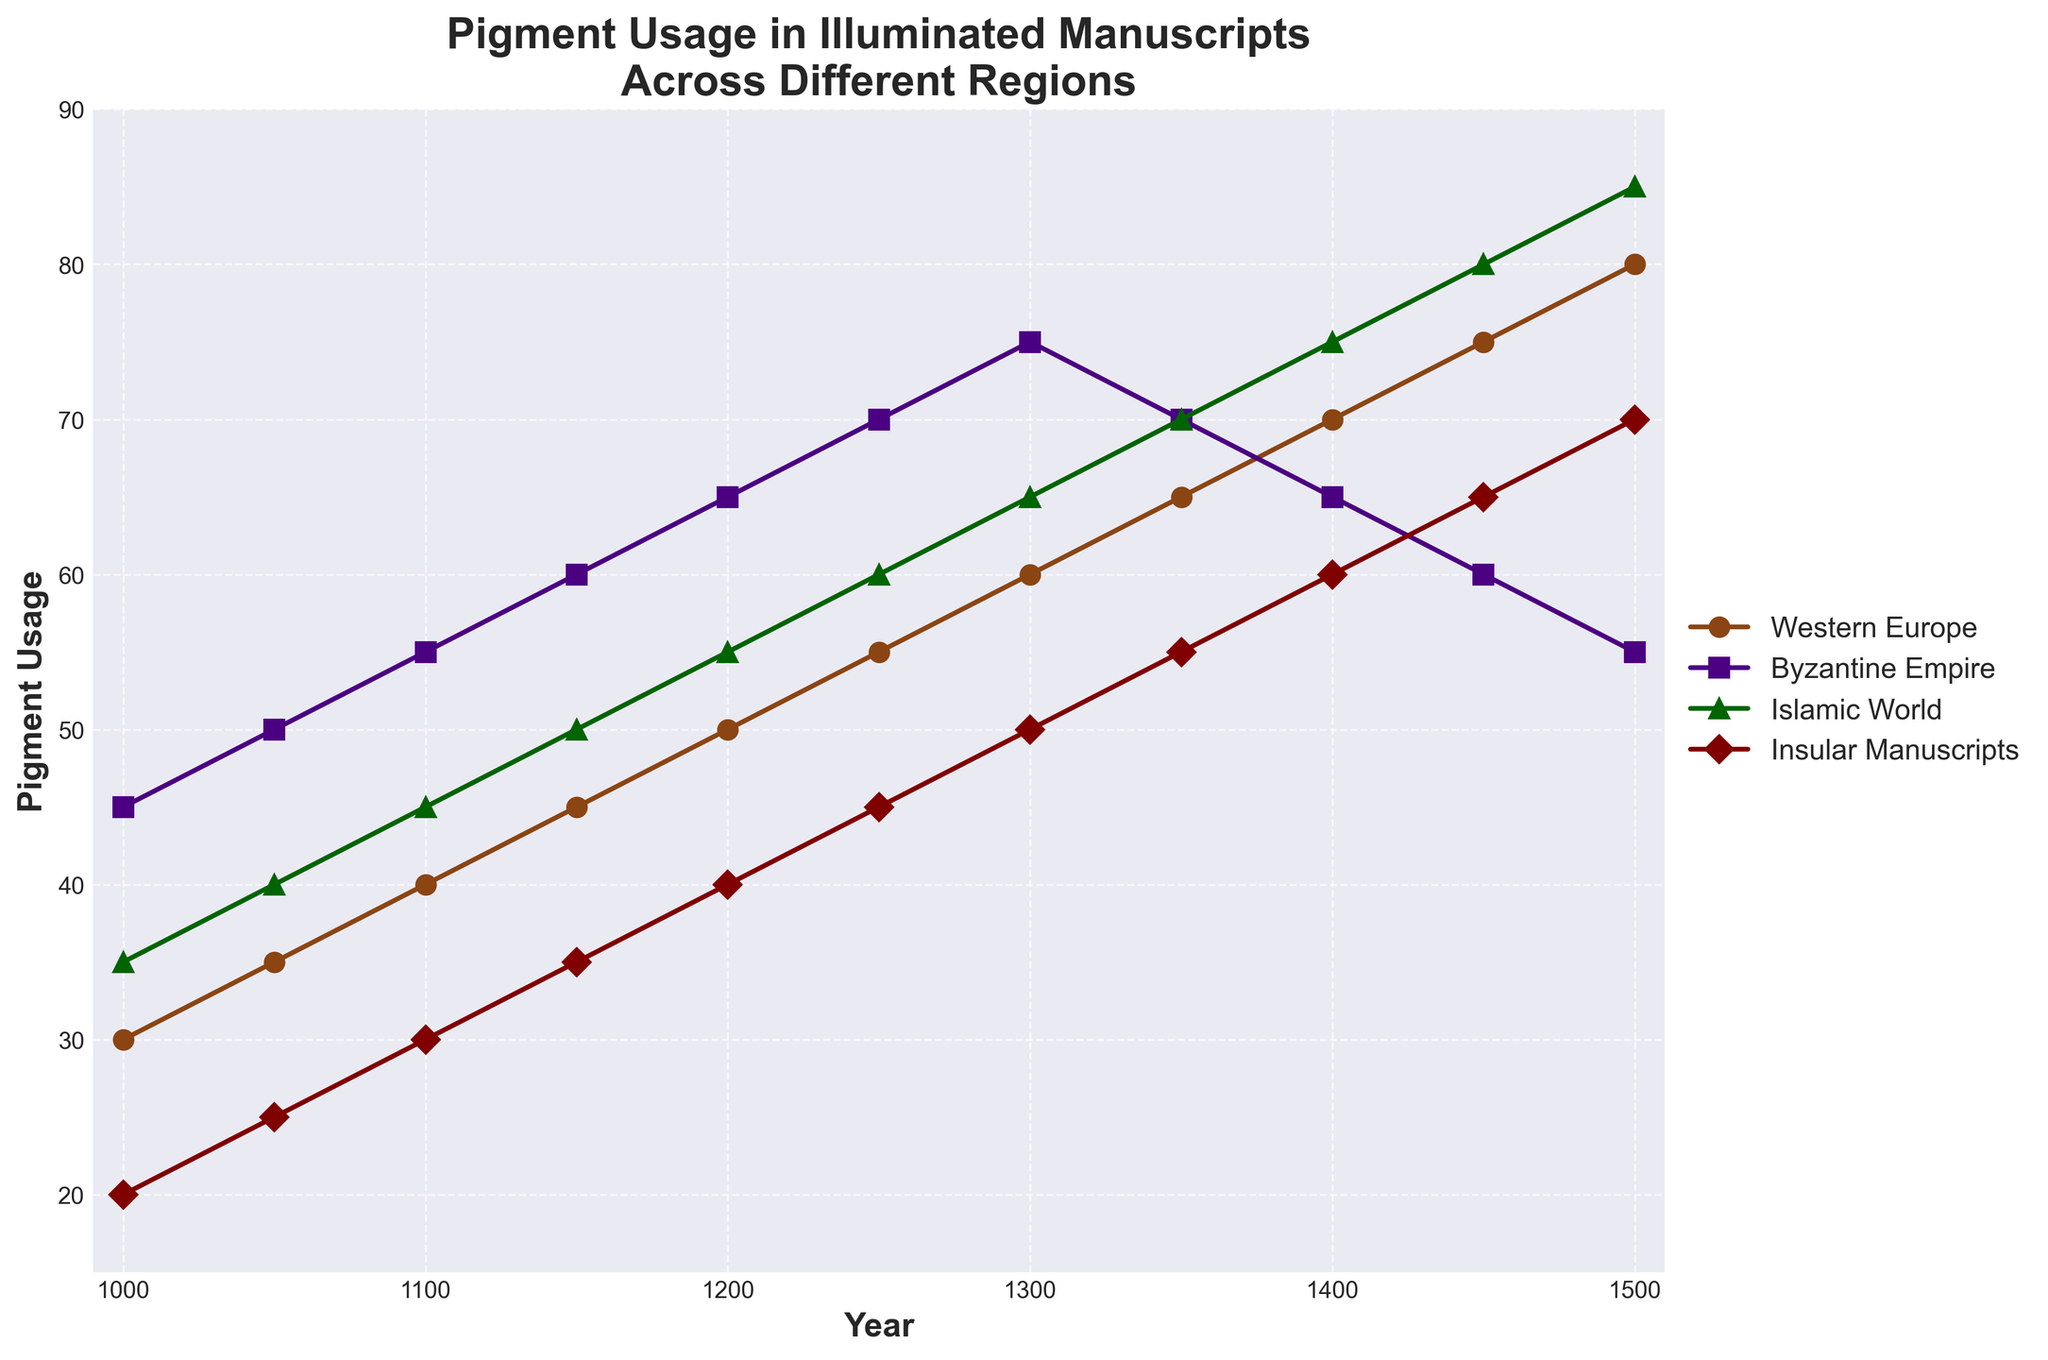What's the trend of pigment usage in Western Europe over time? To identify the trend of pigment usage in Western Europe, look at how the line for Western Europe changes as you move from left to right. The plot shows a consistent upward trend from 30 units in 1000 to 80 units in 1500, implying a steady increase in pigment usage over time.
Answer: Steady increase Which region had the highest pigment usage in 1400? To find the region with the highest pigment usage in 1400, compare the corresponding points on the lines for all regions at the year 1400. The Islamic World has the highest point at 75 units.
Answer: Islamic World By how much did pigment usage in Insular Manuscripts change from 1000 to 1500? To determine the change in pigment usage for Insular Manuscripts, subtract the value in 1000 from the value in 1500. The usage was 20 units in 1000 and rose to 70 units in 1500, making the change 70 - 20 = 50 units.
Answer: 50 units Which two regions had the closest pigment usage values in 1250? Compare the pigment usage values of each pair of regions for the year 1250. Byzantine Empire and Islamic World both had usage values of 70 and 60 units respectively, which are the closest in value.
Answer: Byzantine Empire and Islamic World In which time period did the Byzantine Empire see the largest increase in pigment usage? Examine the differences in pigment usage values for the Byzantine Empire at each interval. The largest increase occurred between 1000 (45 units) and 1050 (50 units), with a 5-unit increase.
Answer: Between 1100 and 1150 What is the average pigment usage in the Islamic World for the years shown? To find the average, add the Islamic World usage values for all years and divide by the number of years: (35+40+45+50+55+60+65+70+75+80+85)/11 = 660/11 ≈ 60 units
Answer: 60 units Which region showed a decline in pigment usage during any period? Visually inspect each line to see if any decrease at any time period. The Byzantine Empire shows a decline from 75 units in 1300 to 70 units in 1350 and further to 65 units in 1400 and 60 in 1450, indicating a decreasing trend during these periods.
Answer: Byzantine Empire How many regions had a pigment usage value above 60 in the year 1450? Count the number of regions with usage values greater than 60 units in 1450. Western Europe (75), Islamic World (80), and Insular Manuscripts (65) all had values above 60.
Answer: Three regions 